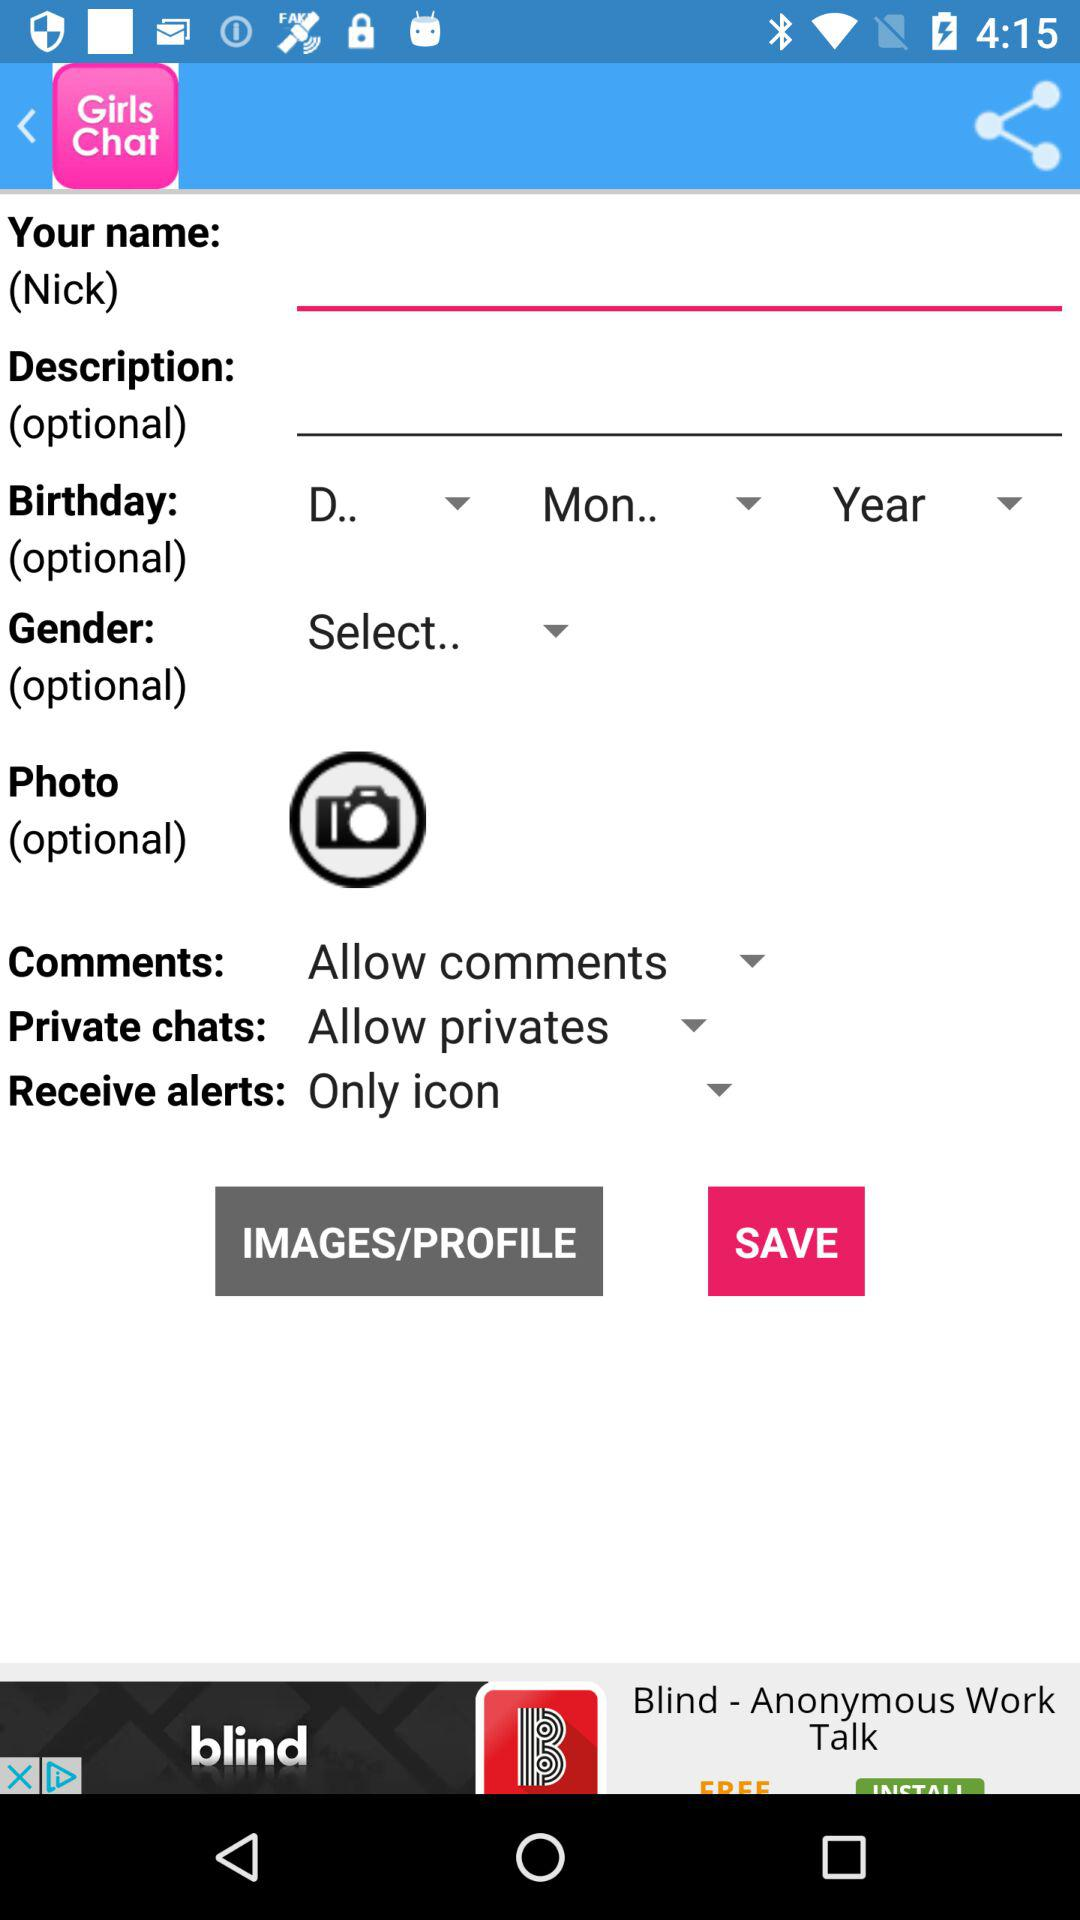What's the setting for "Private chats"? The setting for "Private chats" is "Allow privates". 